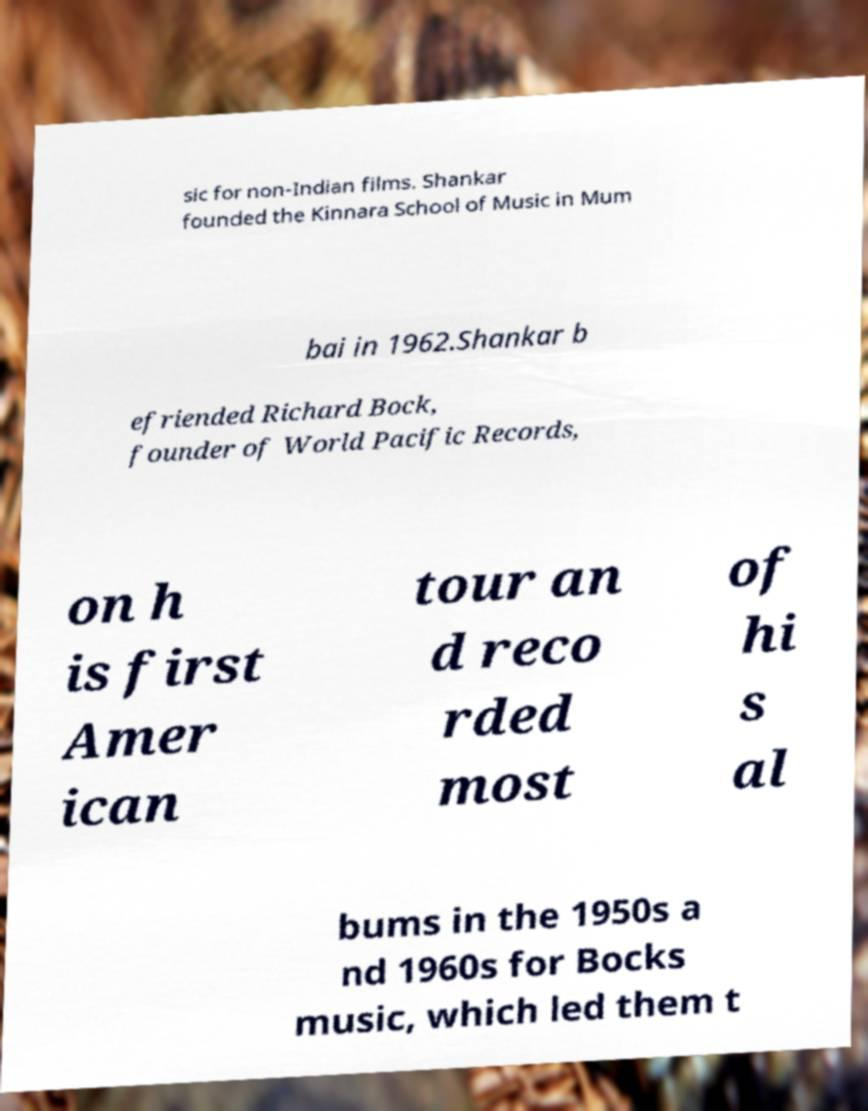Please identify and transcribe the text found in this image. sic for non-Indian films. Shankar founded the Kinnara School of Music in Mum bai in 1962.Shankar b efriended Richard Bock, founder of World Pacific Records, on h is first Amer ican tour an d reco rded most of hi s al bums in the 1950s a nd 1960s for Bocks music, which led them t 